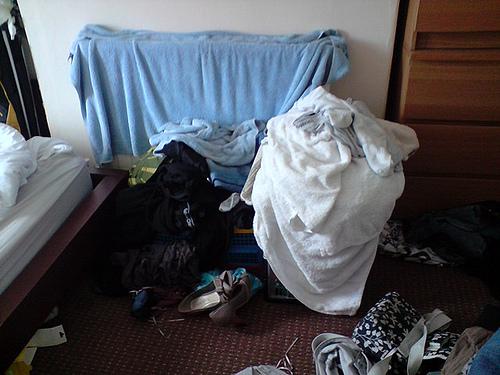Where is the blue towel?
Quick response, please. Hanging. Is the room messy?
Concise answer only. Yes. Can you see a bed?
Be succinct. Yes. 